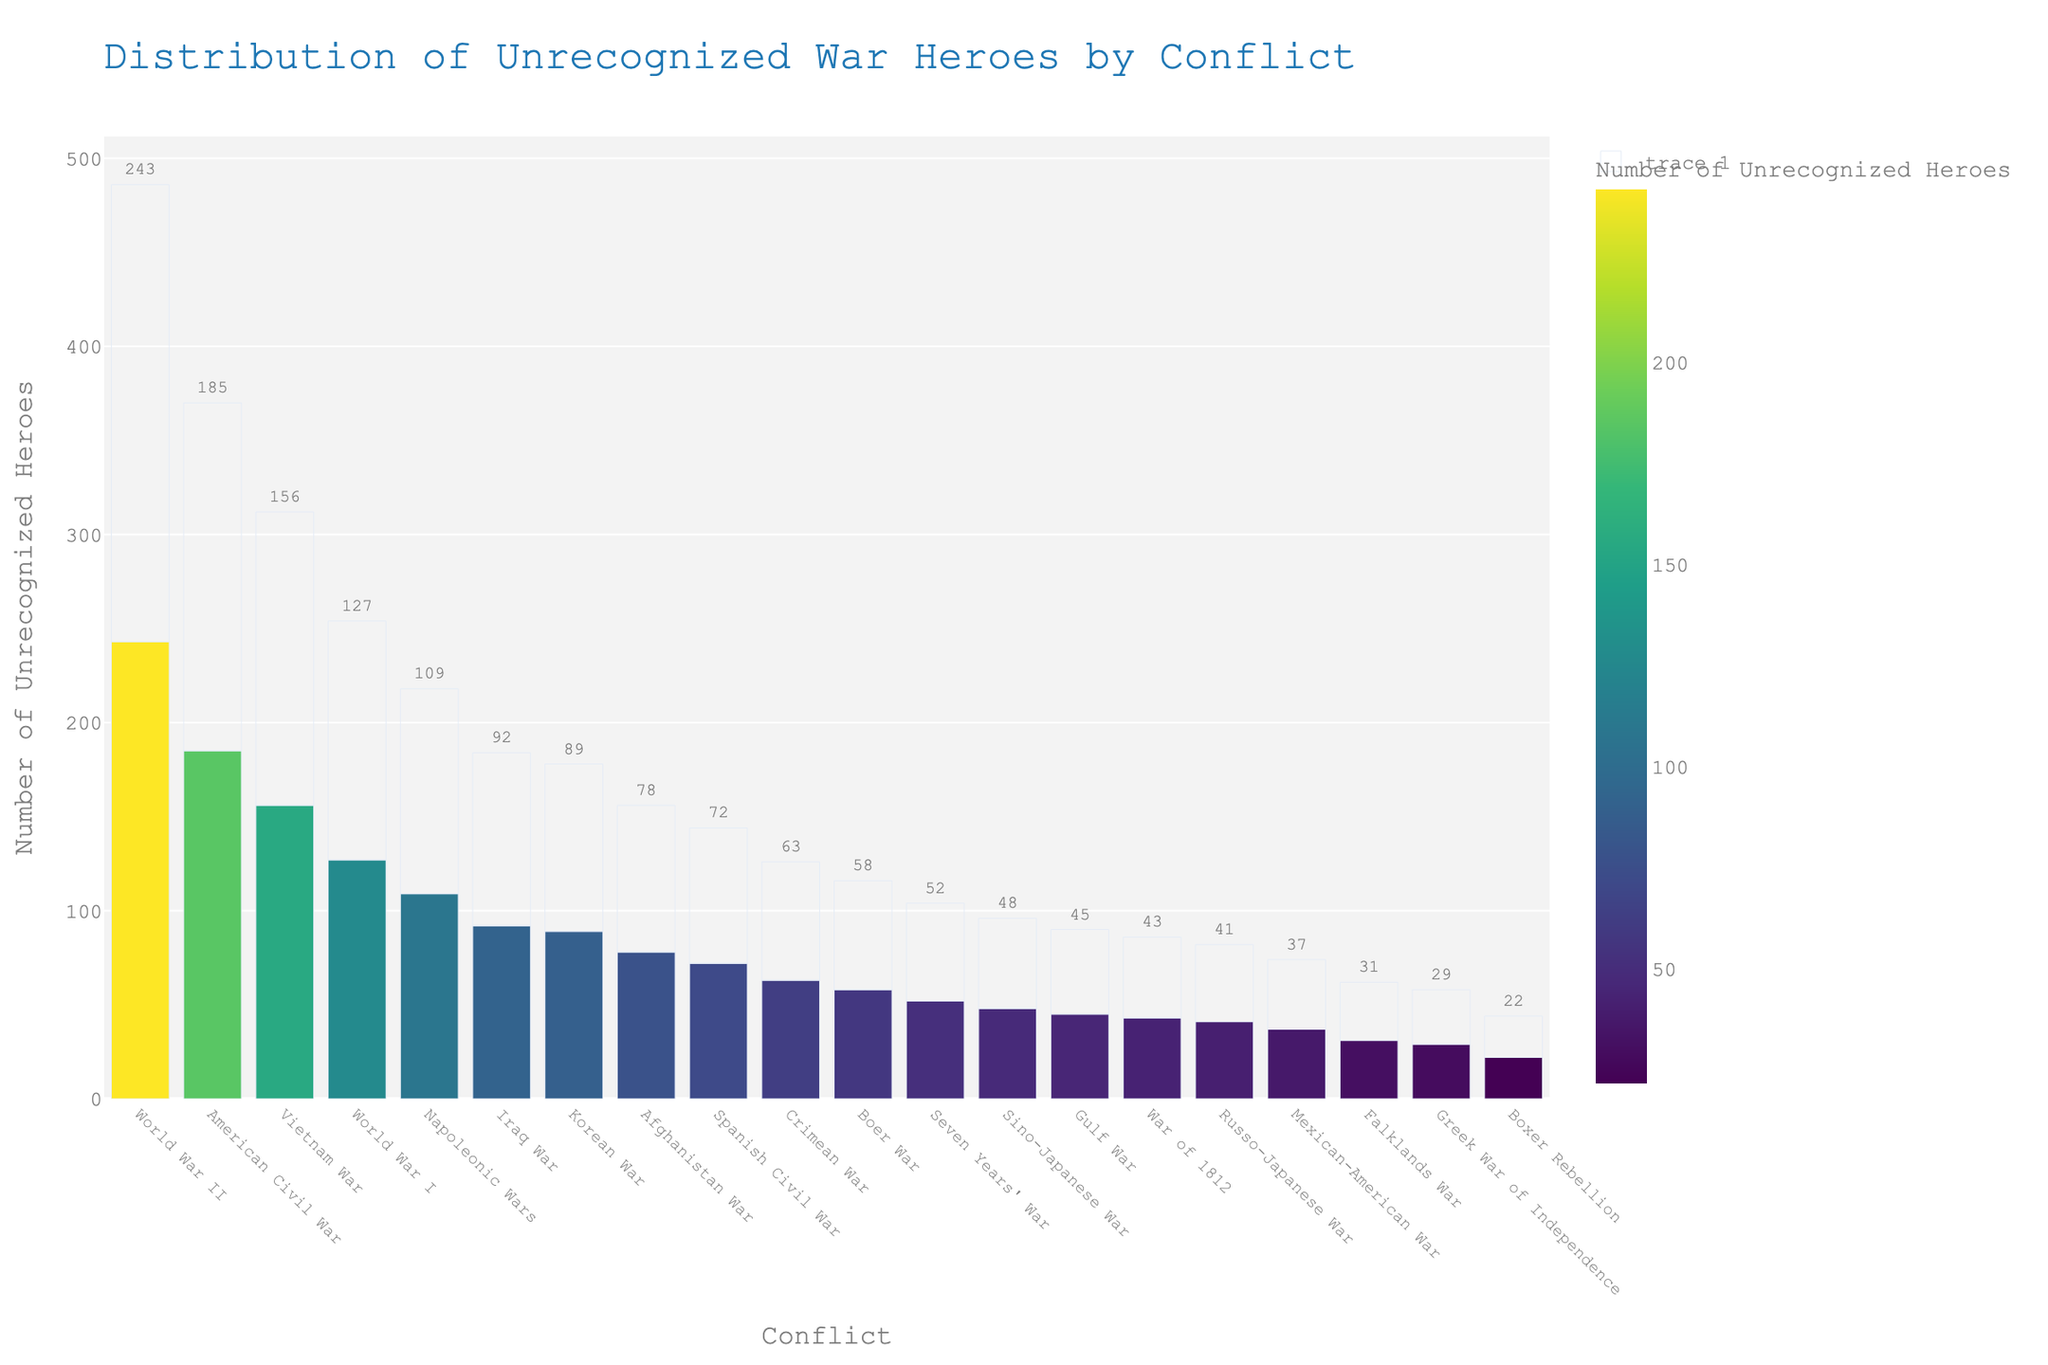Which conflict has the highest number of unrecognized heroes? The bar with the highest value represents the conflict with the most unrecognized heroes. Looking at the chart, the highest bar corresponds to World War II.
Answer: World War II What is the sum of unrecognized heroes for the Korean War and the Vietnam War? Sum the number of unrecognized heroes from the bars representing the Korean War and the Vietnam War. Korean War has 89 and Vietnam War has 156, so 89 + 156 = 245.
Answer: 245 Which two conflicts have an equal number of unrecognized heroes? Look at the bars and find two conflicts with the same height. Both the War of 1812 and the Russo-Japanese War have 43 unrecognized heroes.
Answer: War of 1812, Russo-Japanese War What is the difference in the number of unrecognized heroes between the American Civil War and the Napoleonic Wars? Subtract the number of unrecognized heroes in the Napoleonic Wars from that in the American Civil War. American Civil War has 185, Napoleonic Wars have 109, so the difference is 185 - 109 = 76.
Answer: 76 Which conflict has fewer unrecognized heroes, the Spanish Civil War or the Boer War? Compare the heights of the bars for the Spanish Civil War and the Boer War. The Spanish Civil War has 72 and the Boer War has 58, so the Boer War has fewer unrecognized heroes.
Answer: Boer War What is the sum of the number of unrecognized heroes from World War I, the Gulf War, and the Crimean War? Add the values from the bars for World War I, Gulf War, and Crimean War. World War I has 127, Gulf War has 45, and Crimean War has 63, so the total is 127 + 45 + 63 = 235.
Answer: 235 What is the average number of unrecognized heroes for the conflicts: Seven Years' War, Boxer Rebellion, and Sino-Japanese War? Calculate the sum of the unrecognized heroes for Seven Years' War, Boxer Rebellion, and Sino-Japanese War, then divide by 3. Seven Years' War has 52, Boxer Rebellion has 22, and Sino-Japanese War has 48; sum is 52 + 22 + 48 = 122. Average is 122 / 3 ≈ 40.67.
Answer: 40.67 Between the conflicts listed, which one has the most similar number of unrecognized heroes to the Boxer Rebellion? Find a bar with a height closest to that of the Boxer Rebellion, which has 22 heroes. The Falklands War, with 31 heroes, is the closest.
Answer: Falklands War Which conflict had just under 50 unrecognized heroes? Identify the bar with a value just below 50. The War of 1812 has 43 unrecognized heroes, which is just under 50.
Answer: War of 1812 